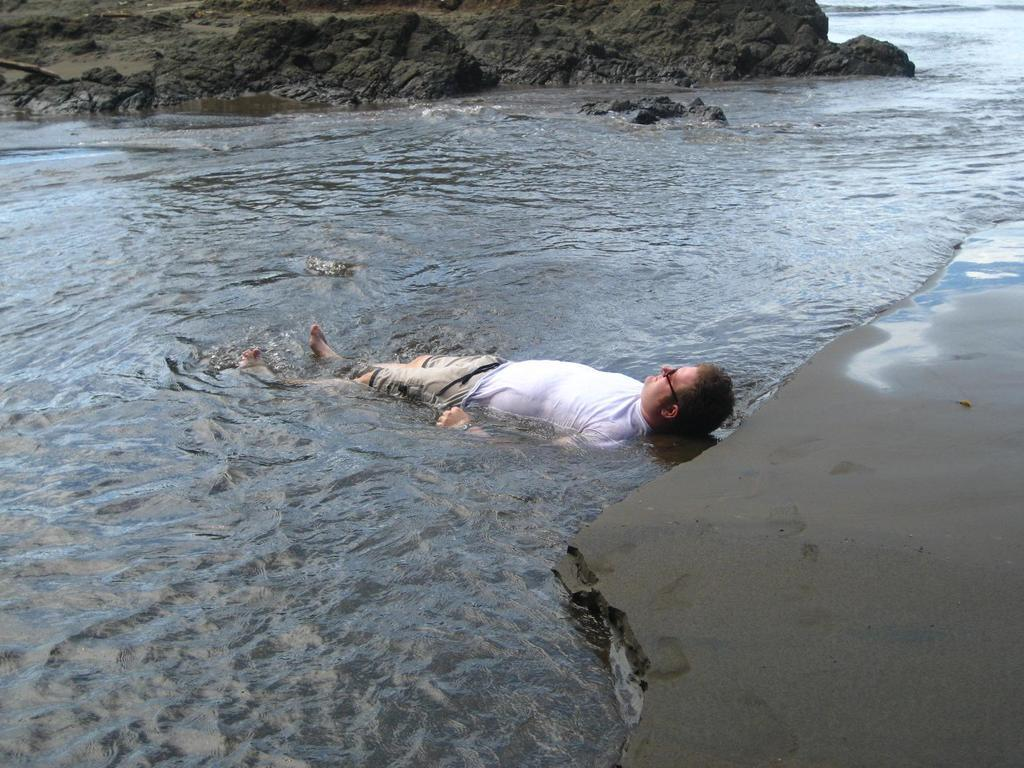What is the person in the image doing? The person is sleeping in the water. What can be seen in the background of the image? Rocks and water are visible in the background of the image. What is the name of the person's daughter in the image? There is no mention of a daughter in the image, so we cannot determine her name. 